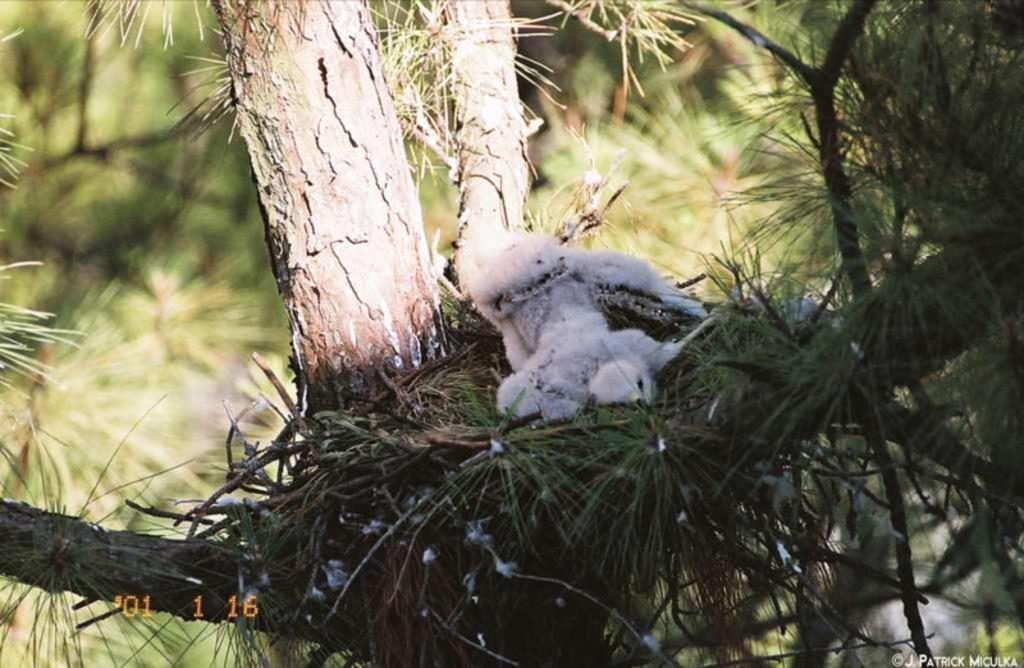Can you describe this image briefly? In this picture I can see a chick on the nest, which is on the branch of the tree, and there is blur background and there are watermarks on the image. 